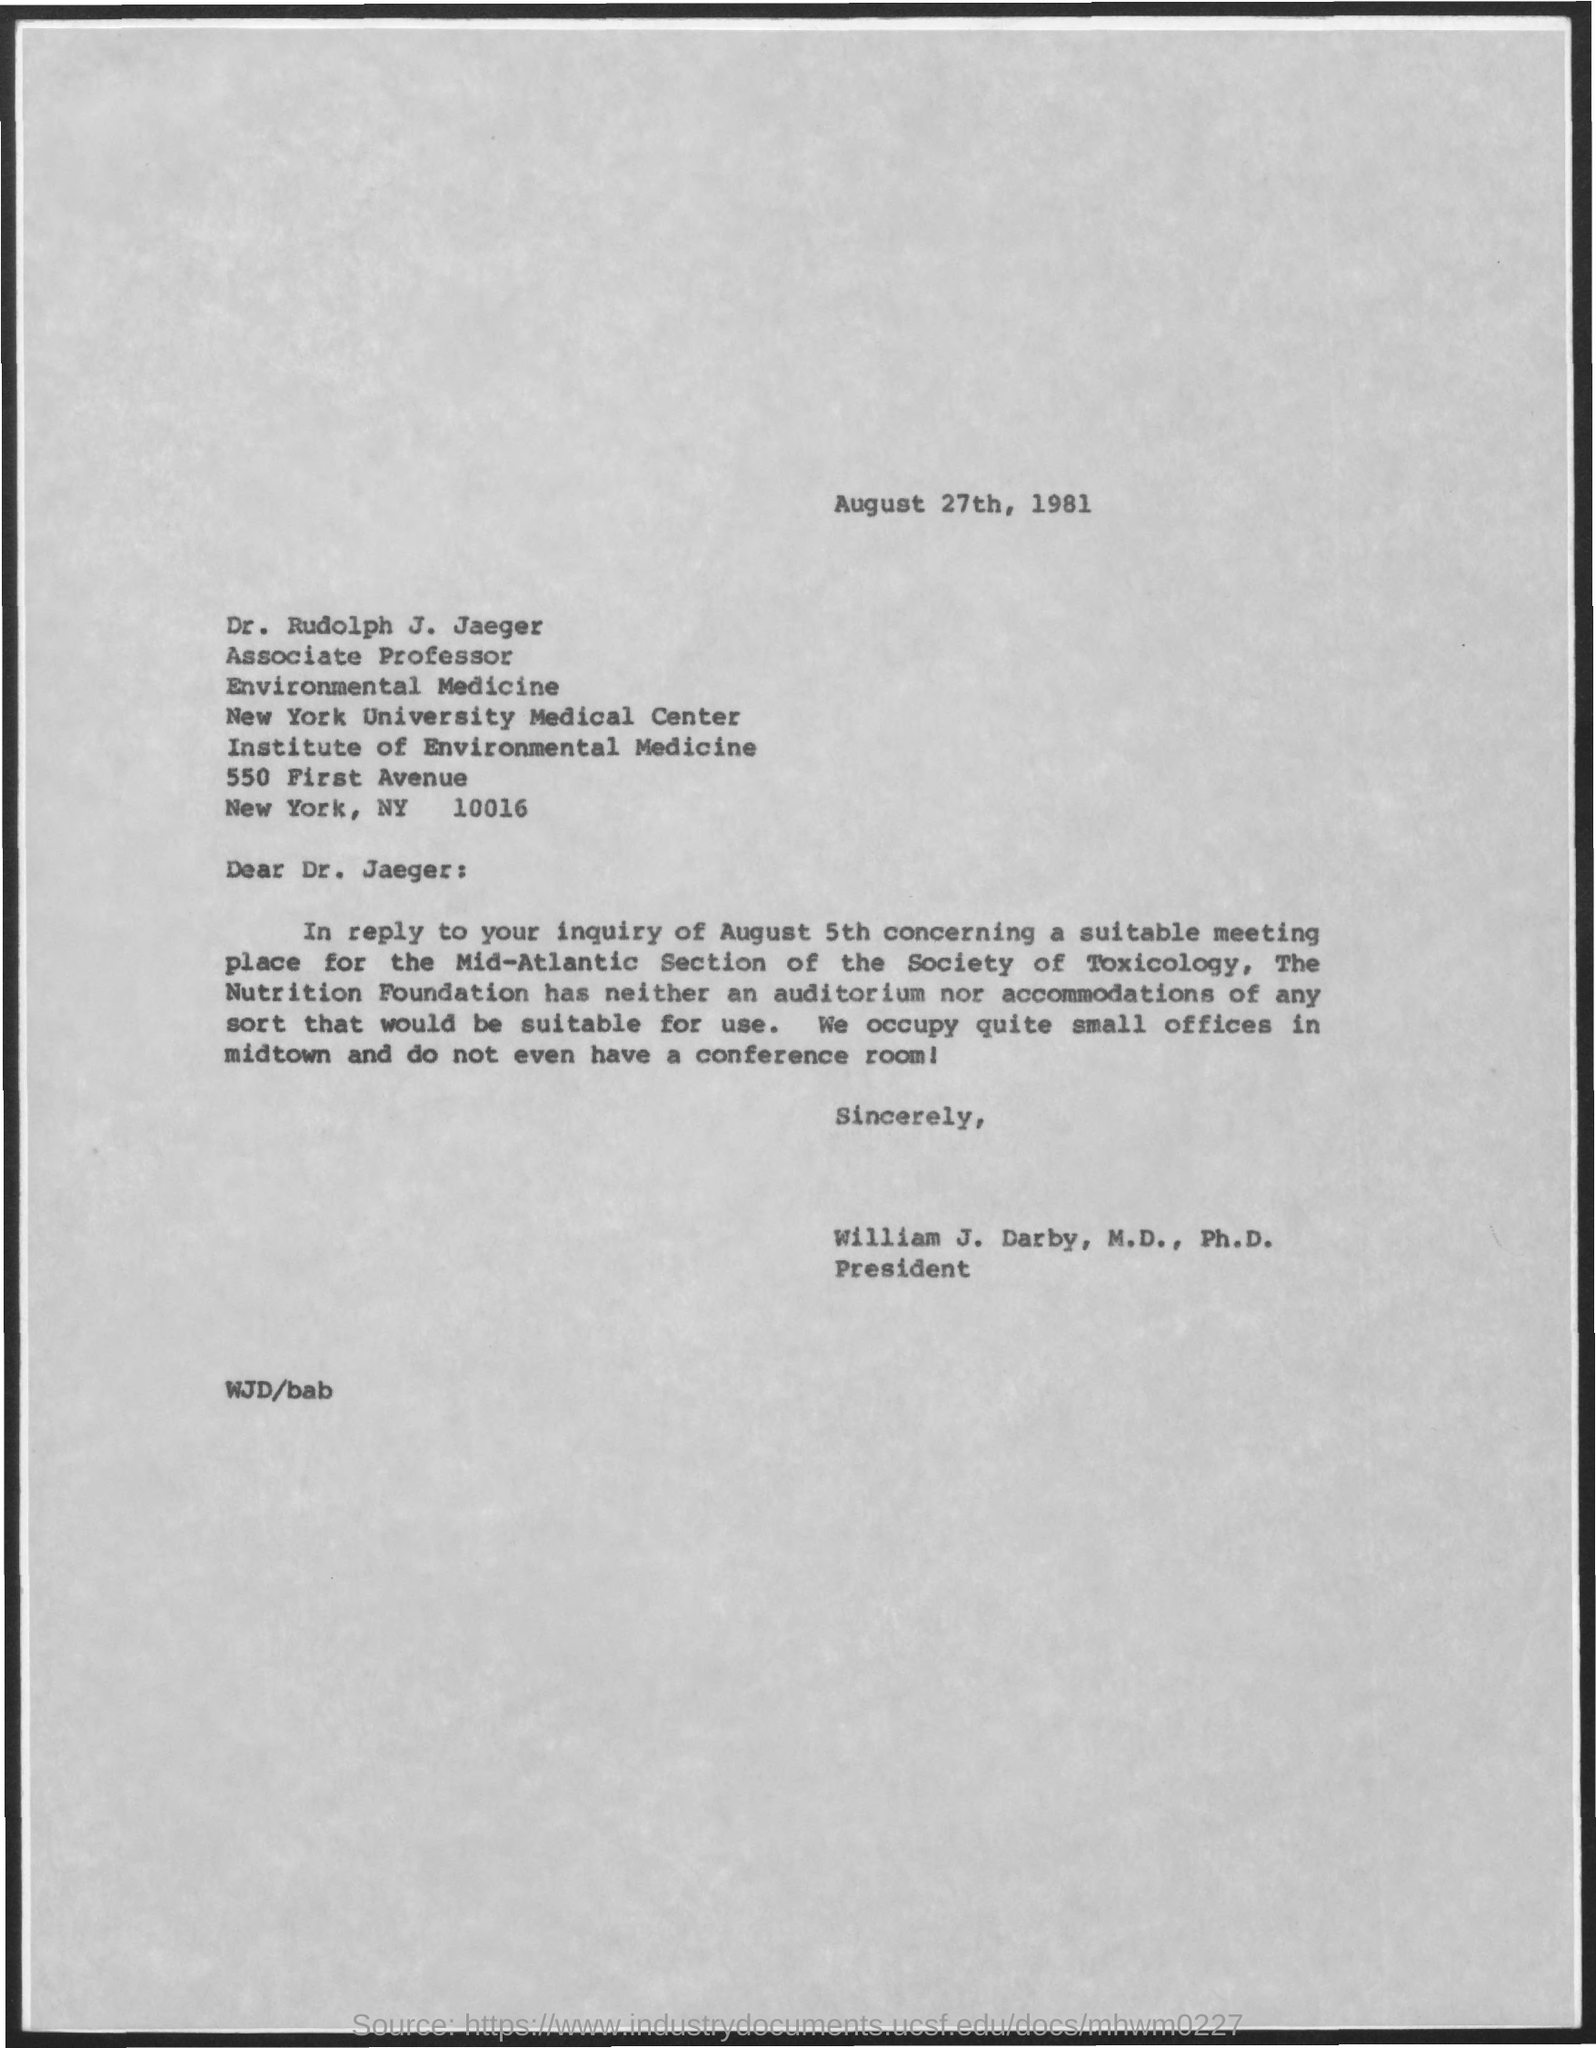What is the date on the document?
Your answer should be very brief. August 27th, 1981. 